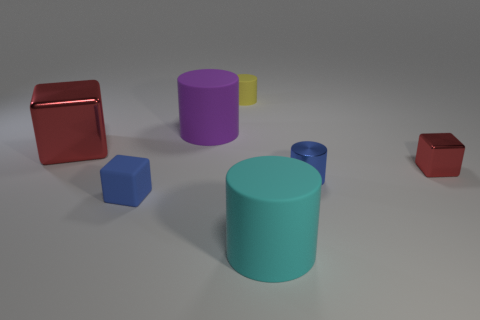Is there a tiny blue rubber object that has the same shape as the big shiny object?
Make the answer very short. Yes. The red thing that is to the left of the matte cylinder that is in front of the big metallic thing that is to the left of the blue metallic cylinder is made of what material?
Your answer should be very brief. Metal. What number of other objects are the same size as the yellow matte cylinder?
Provide a succinct answer. 3. What is the color of the large metal object?
Your answer should be very brief. Red. What number of rubber things are large cyan things or tiny blue cubes?
Make the answer very short. 2. There is a red metal cube on the right side of the big red metallic object to the left of the tiny blue cylinder that is right of the blue rubber cube; how big is it?
Offer a very short reply. Small. How big is the block that is behind the blue rubber thing and left of the big cyan cylinder?
Keep it short and to the point. Large. Is the color of the tiny matte object that is in front of the tiny yellow object the same as the tiny cylinder right of the cyan thing?
Ensure brevity in your answer.  Yes. There is a small yellow rubber cylinder; what number of tiny blocks are right of it?
Provide a short and direct response. 1. There is a red metal cube left of the blue thing right of the large purple matte thing; are there any metallic blocks that are in front of it?
Your response must be concise. Yes. 